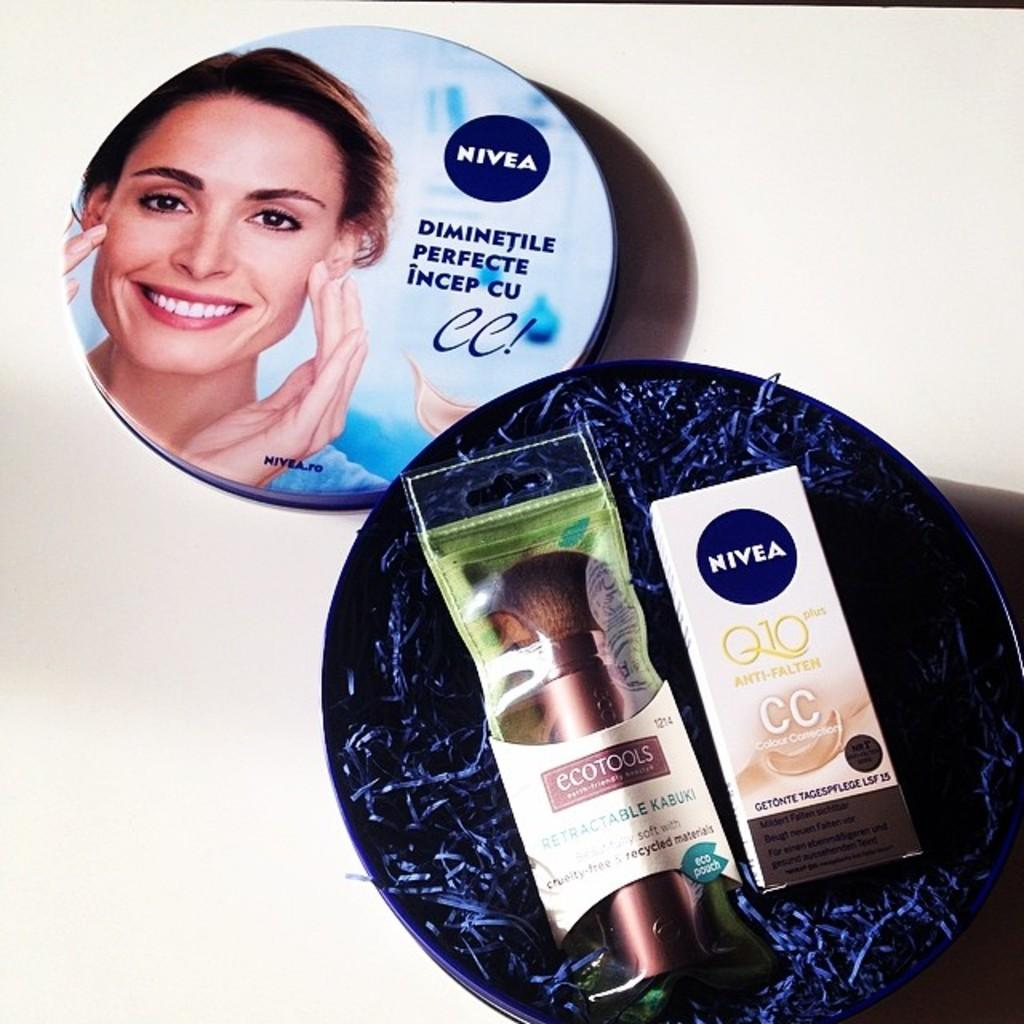Provide a one-sentence caption for the provided image. An opened round box of two Nivea products with the round lid next to the box. 